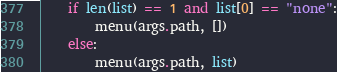Convert code to text. <code><loc_0><loc_0><loc_500><loc_500><_Python_>    if len(list) == 1 and list[0] == "none":
        menu(args.path, [])
    else:
        menu(args.path, list)
</code> 